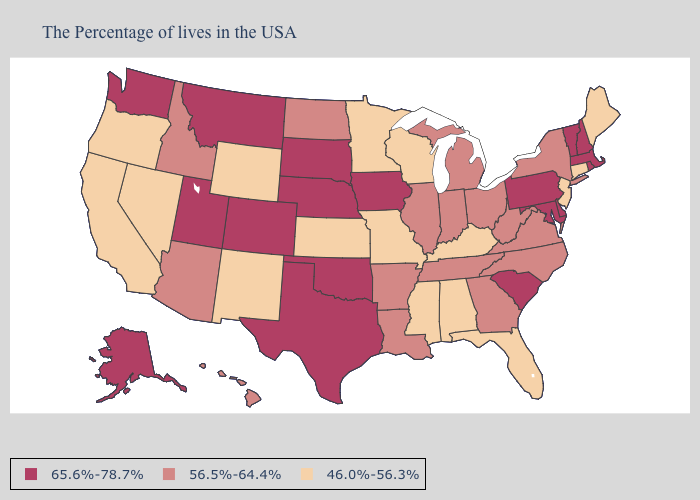Does the first symbol in the legend represent the smallest category?
Short answer required. No. What is the lowest value in the South?
Be succinct. 46.0%-56.3%. Which states have the lowest value in the USA?
Be succinct. Maine, Connecticut, New Jersey, Florida, Kentucky, Alabama, Wisconsin, Mississippi, Missouri, Minnesota, Kansas, Wyoming, New Mexico, Nevada, California, Oregon. Does Colorado have the same value as New York?
Keep it brief. No. Name the states that have a value in the range 56.5%-64.4%?
Quick response, please. New York, Virginia, North Carolina, West Virginia, Ohio, Georgia, Michigan, Indiana, Tennessee, Illinois, Louisiana, Arkansas, North Dakota, Arizona, Idaho, Hawaii. What is the highest value in the Northeast ?
Keep it brief. 65.6%-78.7%. Among the states that border Arkansas , which have the lowest value?
Quick response, please. Mississippi, Missouri. Name the states that have a value in the range 56.5%-64.4%?
Short answer required. New York, Virginia, North Carolina, West Virginia, Ohio, Georgia, Michigan, Indiana, Tennessee, Illinois, Louisiana, Arkansas, North Dakota, Arizona, Idaho, Hawaii. What is the value of Louisiana?
Keep it brief. 56.5%-64.4%. Name the states that have a value in the range 56.5%-64.4%?
Be succinct. New York, Virginia, North Carolina, West Virginia, Ohio, Georgia, Michigan, Indiana, Tennessee, Illinois, Louisiana, Arkansas, North Dakota, Arizona, Idaho, Hawaii. What is the value of South Carolina?
Concise answer only. 65.6%-78.7%. What is the highest value in the USA?
Be succinct. 65.6%-78.7%. Is the legend a continuous bar?
Short answer required. No. Does Florida have a lower value than Wyoming?
Be succinct. No. Name the states that have a value in the range 56.5%-64.4%?
Concise answer only. New York, Virginia, North Carolina, West Virginia, Ohio, Georgia, Michigan, Indiana, Tennessee, Illinois, Louisiana, Arkansas, North Dakota, Arizona, Idaho, Hawaii. 